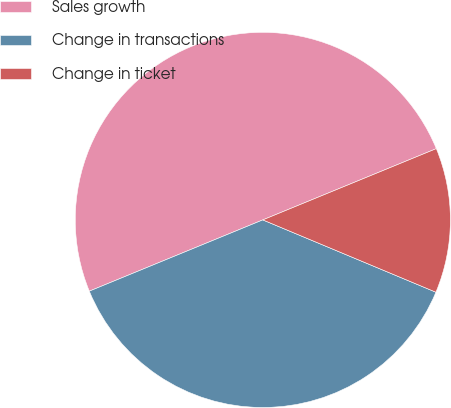Convert chart. <chart><loc_0><loc_0><loc_500><loc_500><pie_chart><fcel>Sales growth<fcel>Change in transactions<fcel>Change in ticket<nl><fcel>50.0%<fcel>37.5%<fcel>12.5%<nl></chart> 